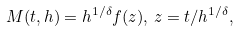Convert formula to latex. <formula><loc_0><loc_0><loc_500><loc_500>M ( t , h ) = h ^ { 1 / \delta } f ( z ) , \, z = t / h ^ { 1 / \delta } ,</formula> 